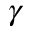<formula> <loc_0><loc_0><loc_500><loc_500>\gamma</formula> 